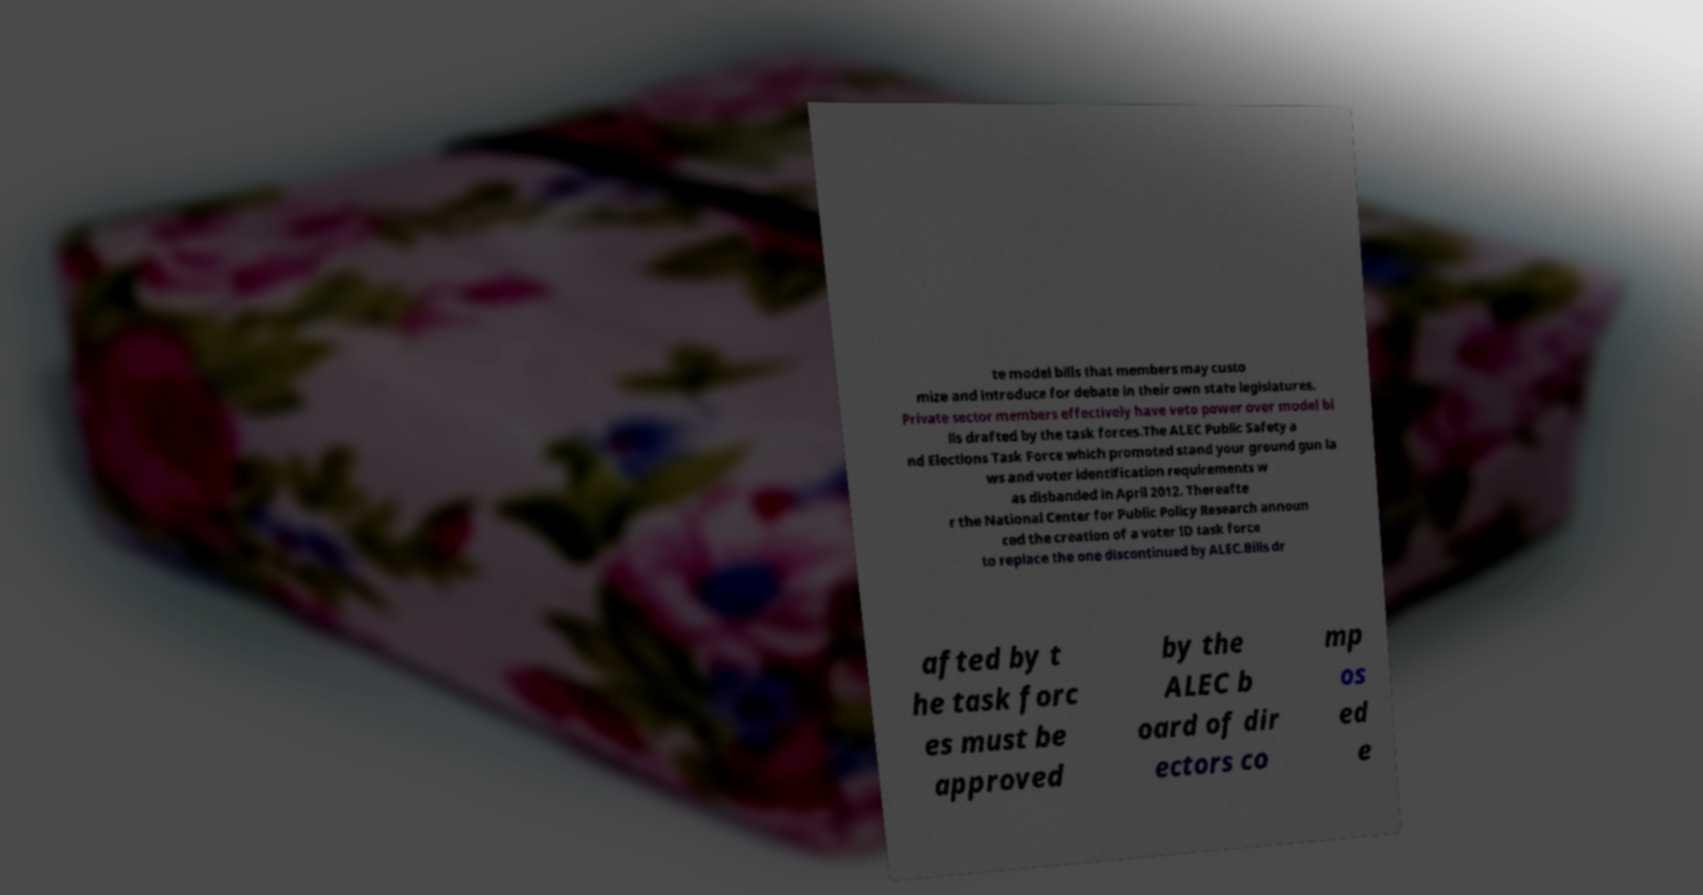What messages or text are displayed in this image? I need them in a readable, typed format. te model bills that members may custo mize and introduce for debate in their own state legislatures. Private sector members effectively have veto power over model bi lls drafted by the task forces.The ALEC Public Safety a nd Elections Task Force which promoted stand your ground gun la ws and voter identification requirements w as disbanded in April 2012. Thereafte r the National Center for Public Policy Research announ ced the creation of a voter ID task force to replace the one discontinued by ALEC.Bills dr afted by t he task forc es must be approved by the ALEC b oard of dir ectors co mp os ed e 